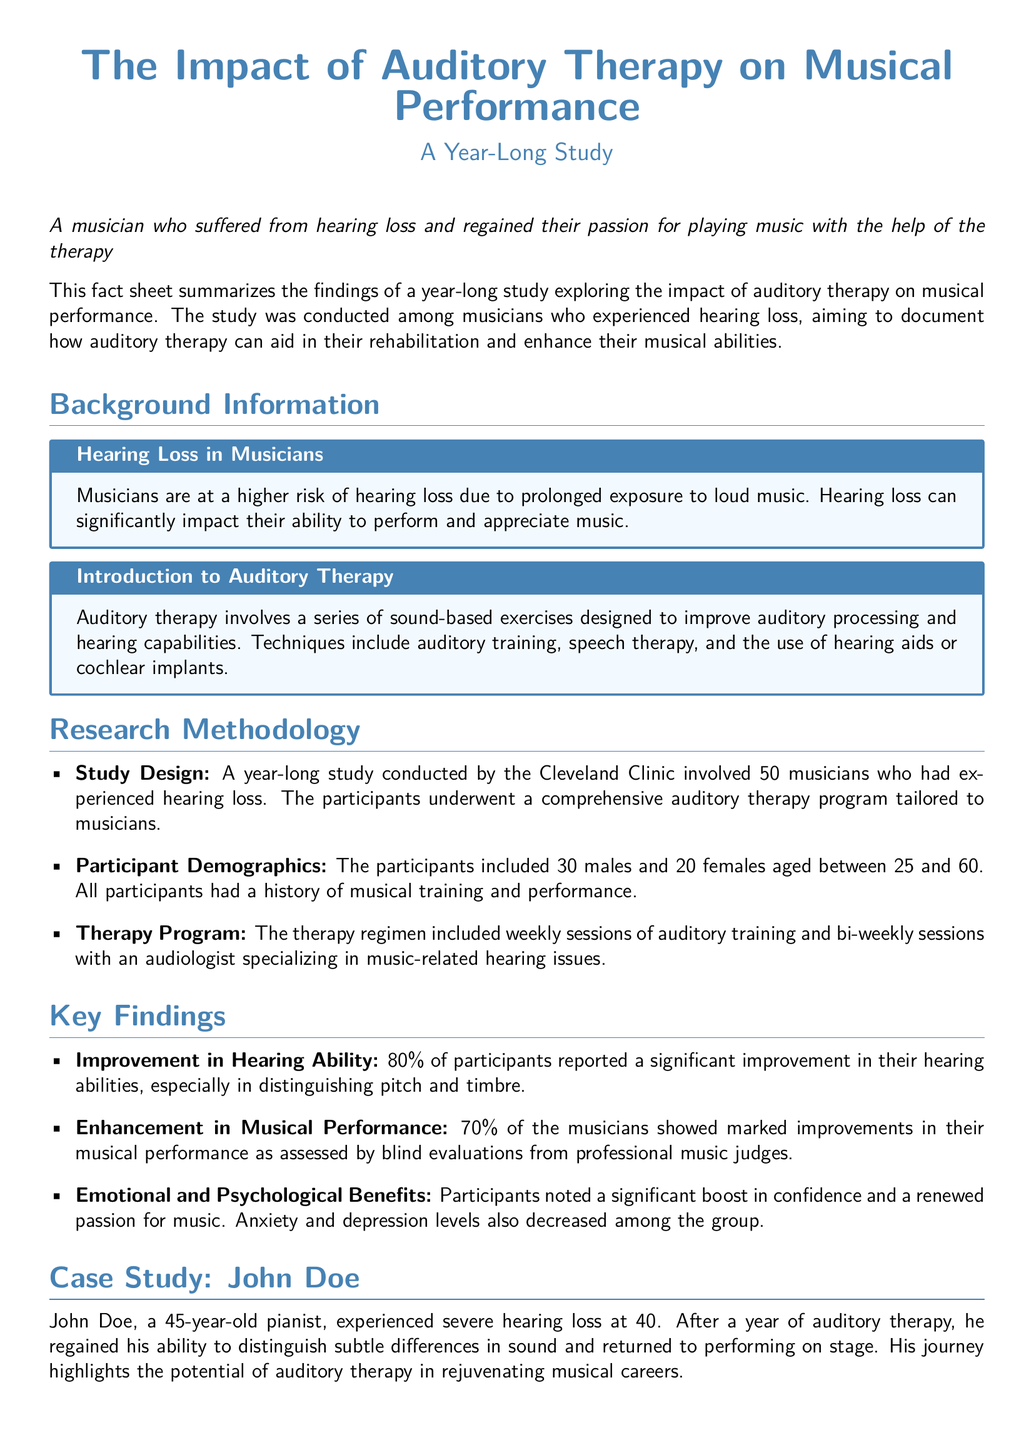What percentage of participants reported improvement in hearing abilities? The document states that 80% of participants reported improvement in their hearing abilities.
Answer: 80% How many males participated in the study? The participant demographics section specifies that there were 30 males in the study.
Answer: 30 What was the therapy regimen's frequency for auditory training? The document mentions that there were weekly sessions of auditory training.
Answer: Weekly What was the age of John Doe when he experienced severe hearing loss? The case study indicates that John Doe was 40 years old at the time of his hearing loss.
Answer: 40 What phrase describes the psychological benefits observed among participants? The text states that participants noted a significant boost in confidence and a renewed passion for music.
Answer: Boost in confidence What was the size of the study group? The document mentions that the study involved 50 musicians who had experienced hearing loss.
Answer: 50 Which center conducted the study? The conclusion indicates that the study was conducted by the Cleveland Clinic.
Answer: Cleveland Clinic What two types of evaluations assessed musical performance improvement? The document refers to blind evaluations from professional music judges.
Answer: Blind evaluations 